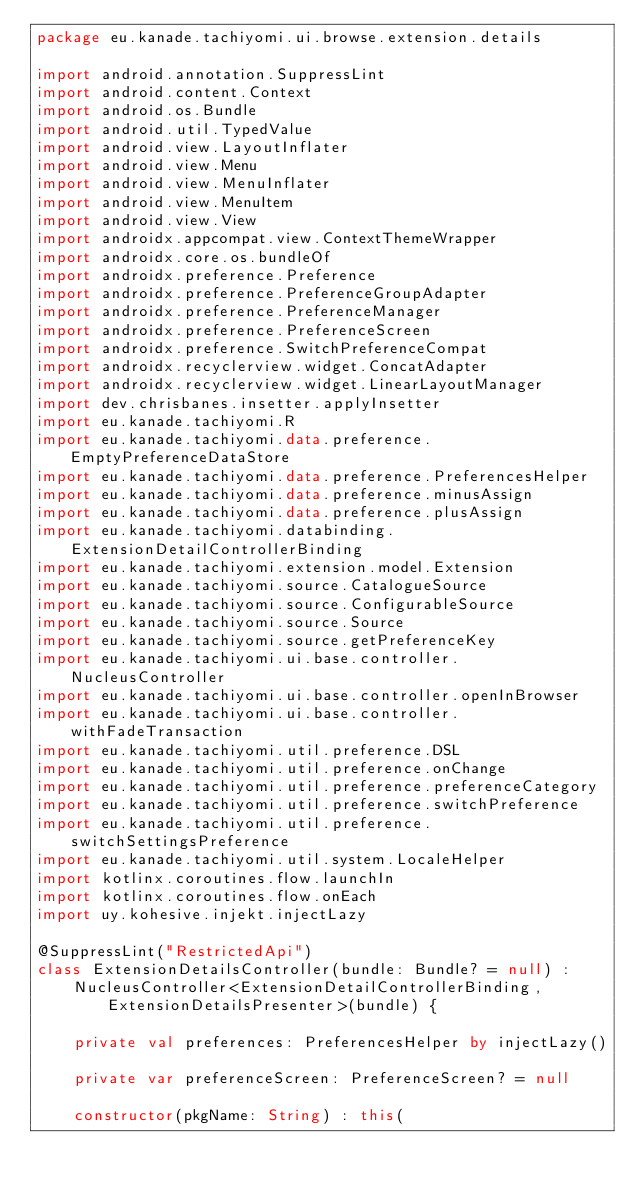Convert code to text. <code><loc_0><loc_0><loc_500><loc_500><_Kotlin_>package eu.kanade.tachiyomi.ui.browse.extension.details

import android.annotation.SuppressLint
import android.content.Context
import android.os.Bundle
import android.util.TypedValue
import android.view.LayoutInflater
import android.view.Menu
import android.view.MenuInflater
import android.view.MenuItem
import android.view.View
import androidx.appcompat.view.ContextThemeWrapper
import androidx.core.os.bundleOf
import androidx.preference.Preference
import androidx.preference.PreferenceGroupAdapter
import androidx.preference.PreferenceManager
import androidx.preference.PreferenceScreen
import androidx.preference.SwitchPreferenceCompat
import androidx.recyclerview.widget.ConcatAdapter
import androidx.recyclerview.widget.LinearLayoutManager
import dev.chrisbanes.insetter.applyInsetter
import eu.kanade.tachiyomi.R
import eu.kanade.tachiyomi.data.preference.EmptyPreferenceDataStore
import eu.kanade.tachiyomi.data.preference.PreferencesHelper
import eu.kanade.tachiyomi.data.preference.minusAssign
import eu.kanade.tachiyomi.data.preference.plusAssign
import eu.kanade.tachiyomi.databinding.ExtensionDetailControllerBinding
import eu.kanade.tachiyomi.extension.model.Extension
import eu.kanade.tachiyomi.source.CatalogueSource
import eu.kanade.tachiyomi.source.ConfigurableSource
import eu.kanade.tachiyomi.source.Source
import eu.kanade.tachiyomi.source.getPreferenceKey
import eu.kanade.tachiyomi.ui.base.controller.NucleusController
import eu.kanade.tachiyomi.ui.base.controller.openInBrowser
import eu.kanade.tachiyomi.ui.base.controller.withFadeTransaction
import eu.kanade.tachiyomi.util.preference.DSL
import eu.kanade.tachiyomi.util.preference.onChange
import eu.kanade.tachiyomi.util.preference.preferenceCategory
import eu.kanade.tachiyomi.util.preference.switchPreference
import eu.kanade.tachiyomi.util.preference.switchSettingsPreference
import eu.kanade.tachiyomi.util.system.LocaleHelper
import kotlinx.coroutines.flow.launchIn
import kotlinx.coroutines.flow.onEach
import uy.kohesive.injekt.injectLazy

@SuppressLint("RestrictedApi")
class ExtensionDetailsController(bundle: Bundle? = null) :
    NucleusController<ExtensionDetailControllerBinding, ExtensionDetailsPresenter>(bundle) {

    private val preferences: PreferencesHelper by injectLazy()

    private var preferenceScreen: PreferenceScreen? = null

    constructor(pkgName: String) : this(</code> 